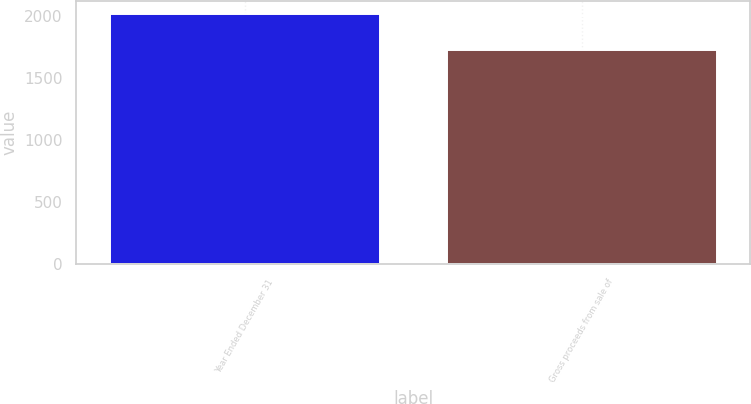Convert chart to OTSL. <chart><loc_0><loc_0><loc_500><loc_500><bar_chart><fcel>Year Ended December 31<fcel>Gross proceeds from sale of<nl><fcel>2016<fcel>1726<nl></chart> 